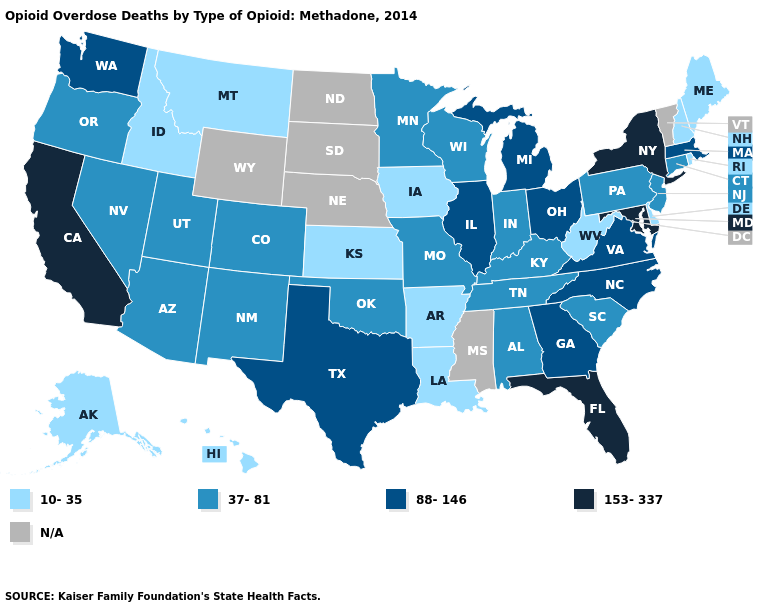Does the first symbol in the legend represent the smallest category?
Concise answer only. Yes. Does the first symbol in the legend represent the smallest category?
Keep it brief. Yes. Which states have the highest value in the USA?
Keep it brief. California, Florida, Maryland, New York. Does New Hampshire have the lowest value in the Northeast?
Concise answer only. Yes. What is the value of Tennessee?
Write a very short answer. 37-81. What is the value of Washington?
Keep it brief. 88-146. Name the states that have a value in the range 10-35?
Concise answer only. Alaska, Arkansas, Delaware, Hawaii, Idaho, Iowa, Kansas, Louisiana, Maine, Montana, New Hampshire, Rhode Island, West Virginia. How many symbols are there in the legend?
Quick response, please. 5. What is the value of Louisiana?
Quick response, please. 10-35. What is the value of North Dakota?
Be succinct. N/A. Among the states that border Mississippi , which have the highest value?
Concise answer only. Alabama, Tennessee. Which states have the lowest value in the South?
Concise answer only. Arkansas, Delaware, Louisiana, West Virginia. Name the states that have a value in the range 88-146?
Be succinct. Georgia, Illinois, Massachusetts, Michigan, North Carolina, Ohio, Texas, Virginia, Washington. What is the highest value in the Northeast ?
Keep it brief. 153-337. 